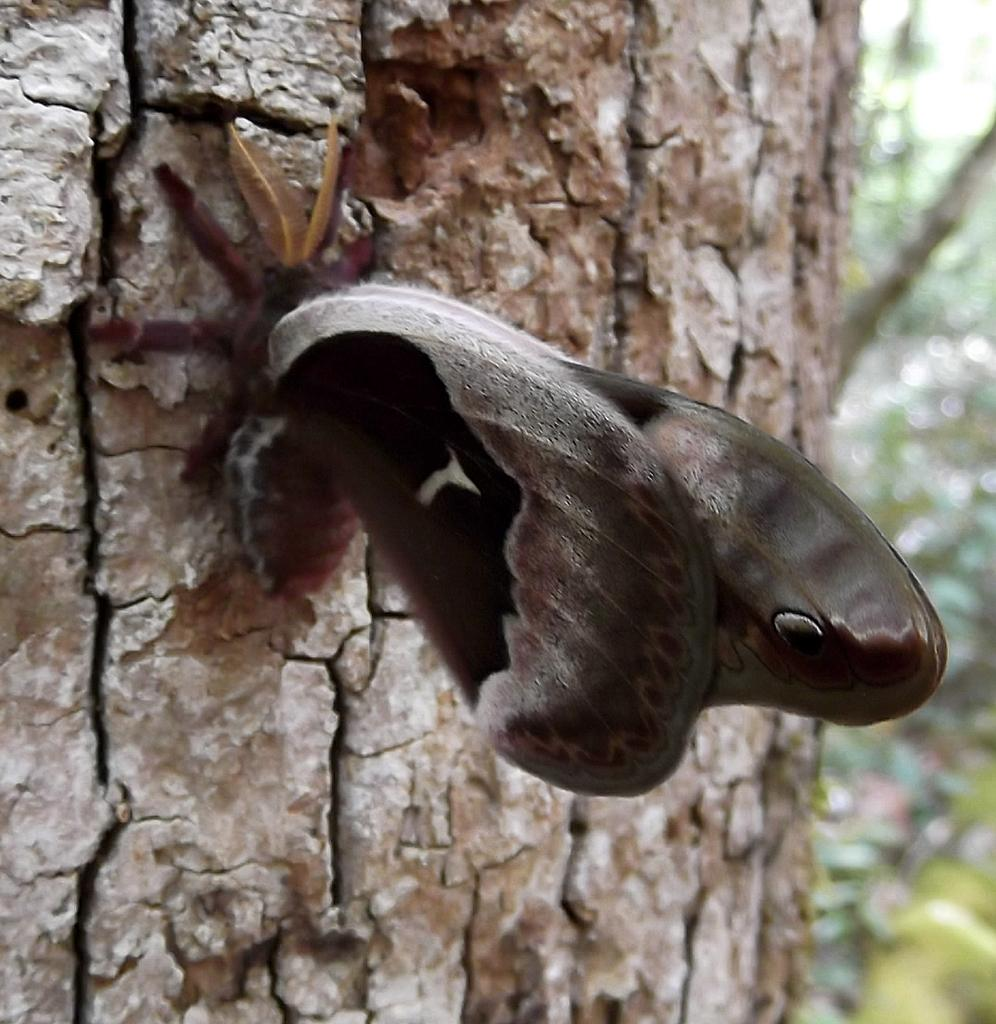What is depicted on the trunk of the tree in the image? There is a butterfly represented on the trunk of a tree in the image. What type of fork can be seen in the image? There is no fork present in the image; it features a butterfly on a tree trunk. What kind of structure is depicted in the image? The image does not depict a structure; it features a butterfly on a tree trunk. 